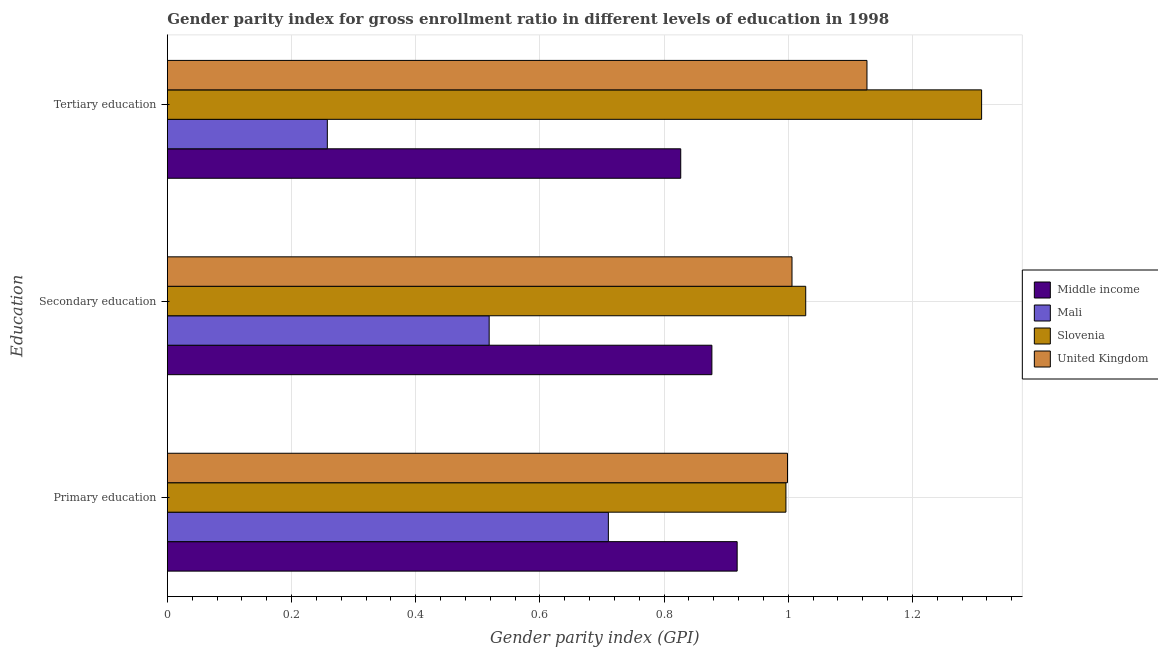How many different coloured bars are there?
Keep it short and to the point. 4. Are the number of bars on each tick of the Y-axis equal?
Ensure brevity in your answer.  Yes. How many bars are there on the 3rd tick from the top?
Provide a succinct answer. 4. How many bars are there on the 3rd tick from the bottom?
Offer a terse response. 4. What is the label of the 3rd group of bars from the top?
Your answer should be compact. Primary education. What is the gender parity index in secondary education in United Kingdom?
Offer a very short reply. 1.01. Across all countries, what is the maximum gender parity index in primary education?
Keep it short and to the point. 1. Across all countries, what is the minimum gender parity index in tertiary education?
Your answer should be very brief. 0.26. In which country was the gender parity index in tertiary education maximum?
Your answer should be very brief. Slovenia. In which country was the gender parity index in primary education minimum?
Offer a terse response. Mali. What is the total gender parity index in primary education in the graph?
Offer a very short reply. 3.62. What is the difference between the gender parity index in primary education in Slovenia and that in United Kingdom?
Your answer should be compact. -0. What is the difference between the gender parity index in tertiary education in Mali and the gender parity index in secondary education in Middle income?
Give a very brief answer. -0.62. What is the average gender parity index in secondary education per country?
Offer a very short reply. 0.86. What is the difference between the gender parity index in tertiary education and gender parity index in primary education in Mali?
Ensure brevity in your answer.  -0.45. In how many countries, is the gender parity index in secondary education greater than 0.36 ?
Keep it short and to the point. 4. What is the ratio of the gender parity index in tertiary education in United Kingdom to that in Middle income?
Provide a succinct answer. 1.36. Is the difference between the gender parity index in tertiary education in Slovenia and Middle income greater than the difference between the gender parity index in secondary education in Slovenia and Middle income?
Provide a short and direct response. Yes. What is the difference between the highest and the second highest gender parity index in primary education?
Your answer should be compact. 0. What is the difference between the highest and the lowest gender parity index in tertiary education?
Offer a terse response. 1.05. Is the sum of the gender parity index in primary education in Middle income and Slovenia greater than the maximum gender parity index in tertiary education across all countries?
Provide a short and direct response. Yes. What does the 2nd bar from the top in Tertiary education represents?
Provide a succinct answer. Slovenia. What does the 3rd bar from the bottom in Tertiary education represents?
Your response must be concise. Slovenia. Are all the bars in the graph horizontal?
Your answer should be very brief. Yes. What is the difference between two consecutive major ticks on the X-axis?
Your response must be concise. 0.2. Are the values on the major ticks of X-axis written in scientific E-notation?
Keep it short and to the point. No. What is the title of the graph?
Offer a terse response. Gender parity index for gross enrollment ratio in different levels of education in 1998. What is the label or title of the X-axis?
Give a very brief answer. Gender parity index (GPI). What is the label or title of the Y-axis?
Offer a terse response. Education. What is the Gender parity index (GPI) in Middle income in Primary education?
Offer a terse response. 0.92. What is the Gender parity index (GPI) of Mali in Primary education?
Make the answer very short. 0.71. What is the Gender parity index (GPI) in Slovenia in Primary education?
Offer a terse response. 1. What is the Gender parity index (GPI) of United Kingdom in Primary education?
Provide a short and direct response. 1. What is the Gender parity index (GPI) of Middle income in Secondary education?
Your answer should be very brief. 0.88. What is the Gender parity index (GPI) of Mali in Secondary education?
Your response must be concise. 0.52. What is the Gender parity index (GPI) of Slovenia in Secondary education?
Your response must be concise. 1.03. What is the Gender parity index (GPI) of United Kingdom in Secondary education?
Ensure brevity in your answer.  1.01. What is the Gender parity index (GPI) in Middle income in Tertiary education?
Your answer should be compact. 0.83. What is the Gender parity index (GPI) in Mali in Tertiary education?
Your answer should be compact. 0.26. What is the Gender parity index (GPI) of Slovenia in Tertiary education?
Offer a terse response. 1.31. What is the Gender parity index (GPI) of United Kingdom in Tertiary education?
Your answer should be compact. 1.13. Across all Education, what is the maximum Gender parity index (GPI) in Middle income?
Give a very brief answer. 0.92. Across all Education, what is the maximum Gender parity index (GPI) of Mali?
Provide a succinct answer. 0.71. Across all Education, what is the maximum Gender parity index (GPI) of Slovenia?
Offer a terse response. 1.31. Across all Education, what is the maximum Gender parity index (GPI) in United Kingdom?
Provide a short and direct response. 1.13. Across all Education, what is the minimum Gender parity index (GPI) of Middle income?
Offer a terse response. 0.83. Across all Education, what is the minimum Gender parity index (GPI) of Mali?
Give a very brief answer. 0.26. Across all Education, what is the minimum Gender parity index (GPI) of Slovenia?
Provide a short and direct response. 1. Across all Education, what is the minimum Gender parity index (GPI) in United Kingdom?
Offer a very short reply. 1. What is the total Gender parity index (GPI) of Middle income in the graph?
Your answer should be compact. 2.62. What is the total Gender parity index (GPI) in Mali in the graph?
Ensure brevity in your answer.  1.49. What is the total Gender parity index (GPI) in Slovenia in the graph?
Offer a very short reply. 3.34. What is the total Gender parity index (GPI) in United Kingdom in the graph?
Offer a terse response. 3.13. What is the difference between the Gender parity index (GPI) of Middle income in Primary education and that in Secondary education?
Make the answer very short. 0.04. What is the difference between the Gender parity index (GPI) in Mali in Primary education and that in Secondary education?
Give a very brief answer. 0.19. What is the difference between the Gender parity index (GPI) of Slovenia in Primary education and that in Secondary education?
Make the answer very short. -0.03. What is the difference between the Gender parity index (GPI) of United Kingdom in Primary education and that in Secondary education?
Offer a terse response. -0.01. What is the difference between the Gender parity index (GPI) in Middle income in Primary education and that in Tertiary education?
Give a very brief answer. 0.09. What is the difference between the Gender parity index (GPI) in Mali in Primary education and that in Tertiary education?
Offer a very short reply. 0.45. What is the difference between the Gender parity index (GPI) in Slovenia in Primary education and that in Tertiary education?
Your answer should be compact. -0.32. What is the difference between the Gender parity index (GPI) in United Kingdom in Primary education and that in Tertiary education?
Ensure brevity in your answer.  -0.13. What is the difference between the Gender parity index (GPI) of Middle income in Secondary education and that in Tertiary education?
Your answer should be very brief. 0.05. What is the difference between the Gender parity index (GPI) in Mali in Secondary education and that in Tertiary education?
Offer a terse response. 0.26. What is the difference between the Gender parity index (GPI) of Slovenia in Secondary education and that in Tertiary education?
Keep it short and to the point. -0.28. What is the difference between the Gender parity index (GPI) of United Kingdom in Secondary education and that in Tertiary education?
Provide a short and direct response. -0.12. What is the difference between the Gender parity index (GPI) in Middle income in Primary education and the Gender parity index (GPI) in Mali in Secondary education?
Your answer should be compact. 0.4. What is the difference between the Gender parity index (GPI) in Middle income in Primary education and the Gender parity index (GPI) in Slovenia in Secondary education?
Ensure brevity in your answer.  -0.11. What is the difference between the Gender parity index (GPI) of Middle income in Primary education and the Gender parity index (GPI) of United Kingdom in Secondary education?
Your response must be concise. -0.09. What is the difference between the Gender parity index (GPI) in Mali in Primary education and the Gender parity index (GPI) in Slovenia in Secondary education?
Your answer should be compact. -0.32. What is the difference between the Gender parity index (GPI) of Mali in Primary education and the Gender parity index (GPI) of United Kingdom in Secondary education?
Give a very brief answer. -0.3. What is the difference between the Gender parity index (GPI) in Slovenia in Primary education and the Gender parity index (GPI) in United Kingdom in Secondary education?
Provide a short and direct response. -0.01. What is the difference between the Gender parity index (GPI) in Middle income in Primary education and the Gender parity index (GPI) in Mali in Tertiary education?
Make the answer very short. 0.66. What is the difference between the Gender parity index (GPI) in Middle income in Primary education and the Gender parity index (GPI) in Slovenia in Tertiary education?
Offer a very short reply. -0.39. What is the difference between the Gender parity index (GPI) of Middle income in Primary education and the Gender parity index (GPI) of United Kingdom in Tertiary education?
Ensure brevity in your answer.  -0.21. What is the difference between the Gender parity index (GPI) in Mali in Primary education and the Gender parity index (GPI) in Slovenia in Tertiary education?
Keep it short and to the point. -0.6. What is the difference between the Gender parity index (GPI) of Mali in Primary education and the Gender parity index (GPI) of United Kingdom in Tertiary education?
Your response must be concise. -0.42. What is the difference between the Gender parity index (GPI) of Slovenia in Primary education and the Gender parity index (GPI) of United Kingdom in Tertiary education?
Keep it short and to the point. -0.13. What is the difference between the Gender parity index (GPI) of Middle income in Secondary education and the Gender parity index (GPI) of Mali in Tertiary education?
Offer a terse response. 0.62. What is the difference between the Gender parity index (GPI) of Middle income in Secondary education and the Gender parity index (GPI) of Slovenia in Tertiary education?
Offer a terse response. -0.43. What is the difference between the Gender parity index (GPI) of Middle income in Secondary education and the Gender parity index (GPI) of United Kingdom in Tertiary education?
Ensure brevity in your answer.  -0.25. What is the difference between the Gender parity index (GPI) of Mali in Secondary education and the Gender parity index (GPI) of Slovenia in Tertiary education?
Your answer should be very brief. -0.79. What is the difference between the Gender parity index (GPI) in Mali in Secondary education and the Gender parity index (GPI) in United Kingdom in Tertiary education?
Keep it short and to the point. -0.61. What is the difference between the Gender parity index (GPI) in Slovenia in Secondary education and the Gender parity index (GPI) in United Kingdom in Tertiary education?
Provide a short and direct response. -0.1. What is the average Gender parity index (GPI) of Middle income per Education?
Your answer should be very brief. 0.87. What is the average Gender parity index (GPI) of Mali per Education?
Your answer should be very brief. 0.5. What is the average Gender parity index (GPI) of Slovenia per Education?
Your answer should be very brief. 1.11. What is the average Gender parity index (GPI) in United Kingdom per Education?
Offer a terse response. 1.04. What is the difference between the Gender parity index (GPI) in Middle income and Gender parity index (GPI) in Mali in Primary education?
Ensure brevity in your answer.  0.21. What is the difference between the Gender parity index (GPI) in Middle income and Gender parity index (GPI) in Slovenia in Primary education?
Your answer should be very brief. -0.08. What is the difference between the Gender parity index (GPI) in Middle income and Gender parity index (GPI) in United Kingdom in Primary education?
Ensure brevity in your answer.  -0.08. What is the difference between the Gender parity index (GPI) in Mali and Gender parity index (GPI) in Slovenia in Primary education?
Your answer should be compact. -0.29. What is the difference between the Gender parity index (GPI) of Mali and Gender parity index (GPI) of United Kingdom in Primary education?
Ensure brevity in your answer.  -0.29. What is the difference between the Gender parity index (GPI) in Slovenia and Gender parity index (GPI) in United Kingdom in Primary education?
Provide a short and direct response. -0. What is the difference between the Gender parity index (GPI) in Middle income and Gender parity index (GPI) in Mali in Secondary education?
Make the answer very short. 0.36. What is the difference between the Gender parity index (GPI) in Middle income and Gender parity index (GPI) in Slovenia in Secondary education?
Keep it short and to the point. -0.15. What is the difference between the Gender parity index (GPI) of Middle income and Gender parity index (GPI) of United Kingdom in Secondary education?
Keep it short and to the point. -0.13. What is the difference between the Gender parity index (GPI) of Mali and Gender parity index (GPI) of Slovenia in Secondary education?
Make the answer very short. -0.51. What is the difference between the Gender parity index (GPI) of Mali and Gender parity index (GPI) of United Kingdom in Secondary education?
Ensure brevity in your answer.  -0.49. What is the difference between the Gender parity index (GPI) of Slovenia and Gender parity index (GPI) of United Kingdom in Secondary education?
Ensure brevity in your answer.  0.02. What is the difference between the Gender parity index (GPI) of Middle income and Gender parity index (GPI) of Mali in Tertiary education?
Offer a very short reply. 0.57. What is the difference between the Gender parity index (GPI) in Middle income and Gender parity index (GPI) in Slovenia in Tertiary education?
Ensure brevity in your answer.  -0.48. What is the difference between the Gender parity index (GPI) in Middle income and Gender parity index (GPI) in United Kingdom in Tertiary education?
Provide a succinct answer. -0.3. What is the difference between the Gender parity index (GPI) in Mali and Gender parity index (GPI) in Slovenia in Tertiary education?
Ensure brevity in your answer.  -1.05. What is the difference between the Gender parity index (GPI) in Mali and Gender parity index (GPI) in United Kingdom in Tertiary education?
Make the answer very short. -0.87. What is the difference between the Gender parity index (GPI) of Slovenia and Gender parity index (GPI) of United Kingdom in Tertiary education?
Offer a terse response. 0.18. What is the ratio of the Gender parity index (GPI) in Middle income in Primary education to that in Secondary education?
Your answer should be very brief. 1.05. What is the ratio of the Gender parity index (GPI) in Mali in Primary education to that in Secondary education?
Offer a very short reply. 1.37. What is the ratio of the Gender parity index (GPI) in Slovenia in Primary education to that in Secondary education?
Your response must be concise. 0.97. What is the ratio of the Gender parity index (GPI) in United Kingdom in Primary education to that in Secondary education?
Provide a short and direct response. 0.99. What is the ratio of the Gender parity index (GPI) of Middle income in Primary education to that in Tertiary education?
Offer a very short reply. 1.11. What is the ratio of the Gender parity index (GPI) in Mali in Primary education to that in Tertiary education?
Offer a terse response. 2.76. What is the ratio of the Gender parity index (GPI) of Slovenia in Primary education to that in Tertiary education?
Your answer should be compact. 0.76. What is the ratio of the Gender parity index (GPI) in United Kingdom in Primary education to that in Tertiary education?
Your answer should be compact. 0.89. What is the ratio of the Gender parity index (GPI) of Middle income in Secondary education to that in Tertiary education?
Give a very brief answer. 1.06. What is the ratio of the Gender parity index (GPI) in Mali in Secondary education to that in Tertiary education?
Ensure brevity in your answer.  2.01. What is the ratio of the Gender parity index (GPI) of Slovenia in Secondary education to that in Tertiary education?
Make the answer very short. 0.78. What is the ratio of the Gender parity index (GPI) in United Kingdom in Secondary education to that in Tertiary education?
Provide a succinct answer. 0.89. What is the difference between the highest and the second highest Gender parity index (GPI) of Middle income?
Provide a succinct answer. 0.04. What is the difference between the highest and the second highest Gender parity index (GPI) in Mali?
Your answer should be very brief. 0.19. What is the difference between the highest and the second highest Gender parity index (GPI) in Slovenia?
Your answer should be very brief. 0.28. What is the difference between the highest and the second highest Gender parity index (GPI) in United Kingdom?
Your answer should be very brief. 0.12. What is the difference between the highest and the lowest Gender parity index (GPI) of Middle income?
Keep it short and to the point. 0.09. What is the difference between the highest and the lowest Gender parity index (GPI) of Mali?
Keep it short and to the point. 0.45. What is the difference between the highest and the lowest Gender parity index (GPI) of Slovenia?
Offer a terse response. 0.32. What is the difference between the highest and the lowest Gender parity index (GPI) in United Kingdom?
Ensure brevity in your answer.  0.13. 